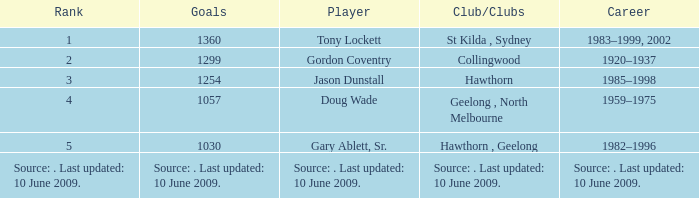What is the rank of player Jason Dunstall? 3.0. 